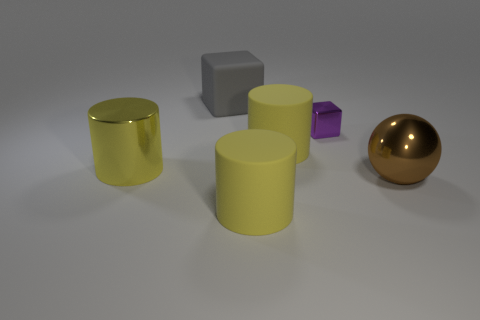Can you estimate the sizes of these objects relative to each other? Certainly, relative to each other, the gold sphere and the gray cube appear to be the largest objects. The yellow cylinders seem to be of medium size, and the tiny purple cube is the smallest of the lot. There are no clear reference objects for exact measurements, but by comparing the objects to each other, these size relationships can be inferred. 